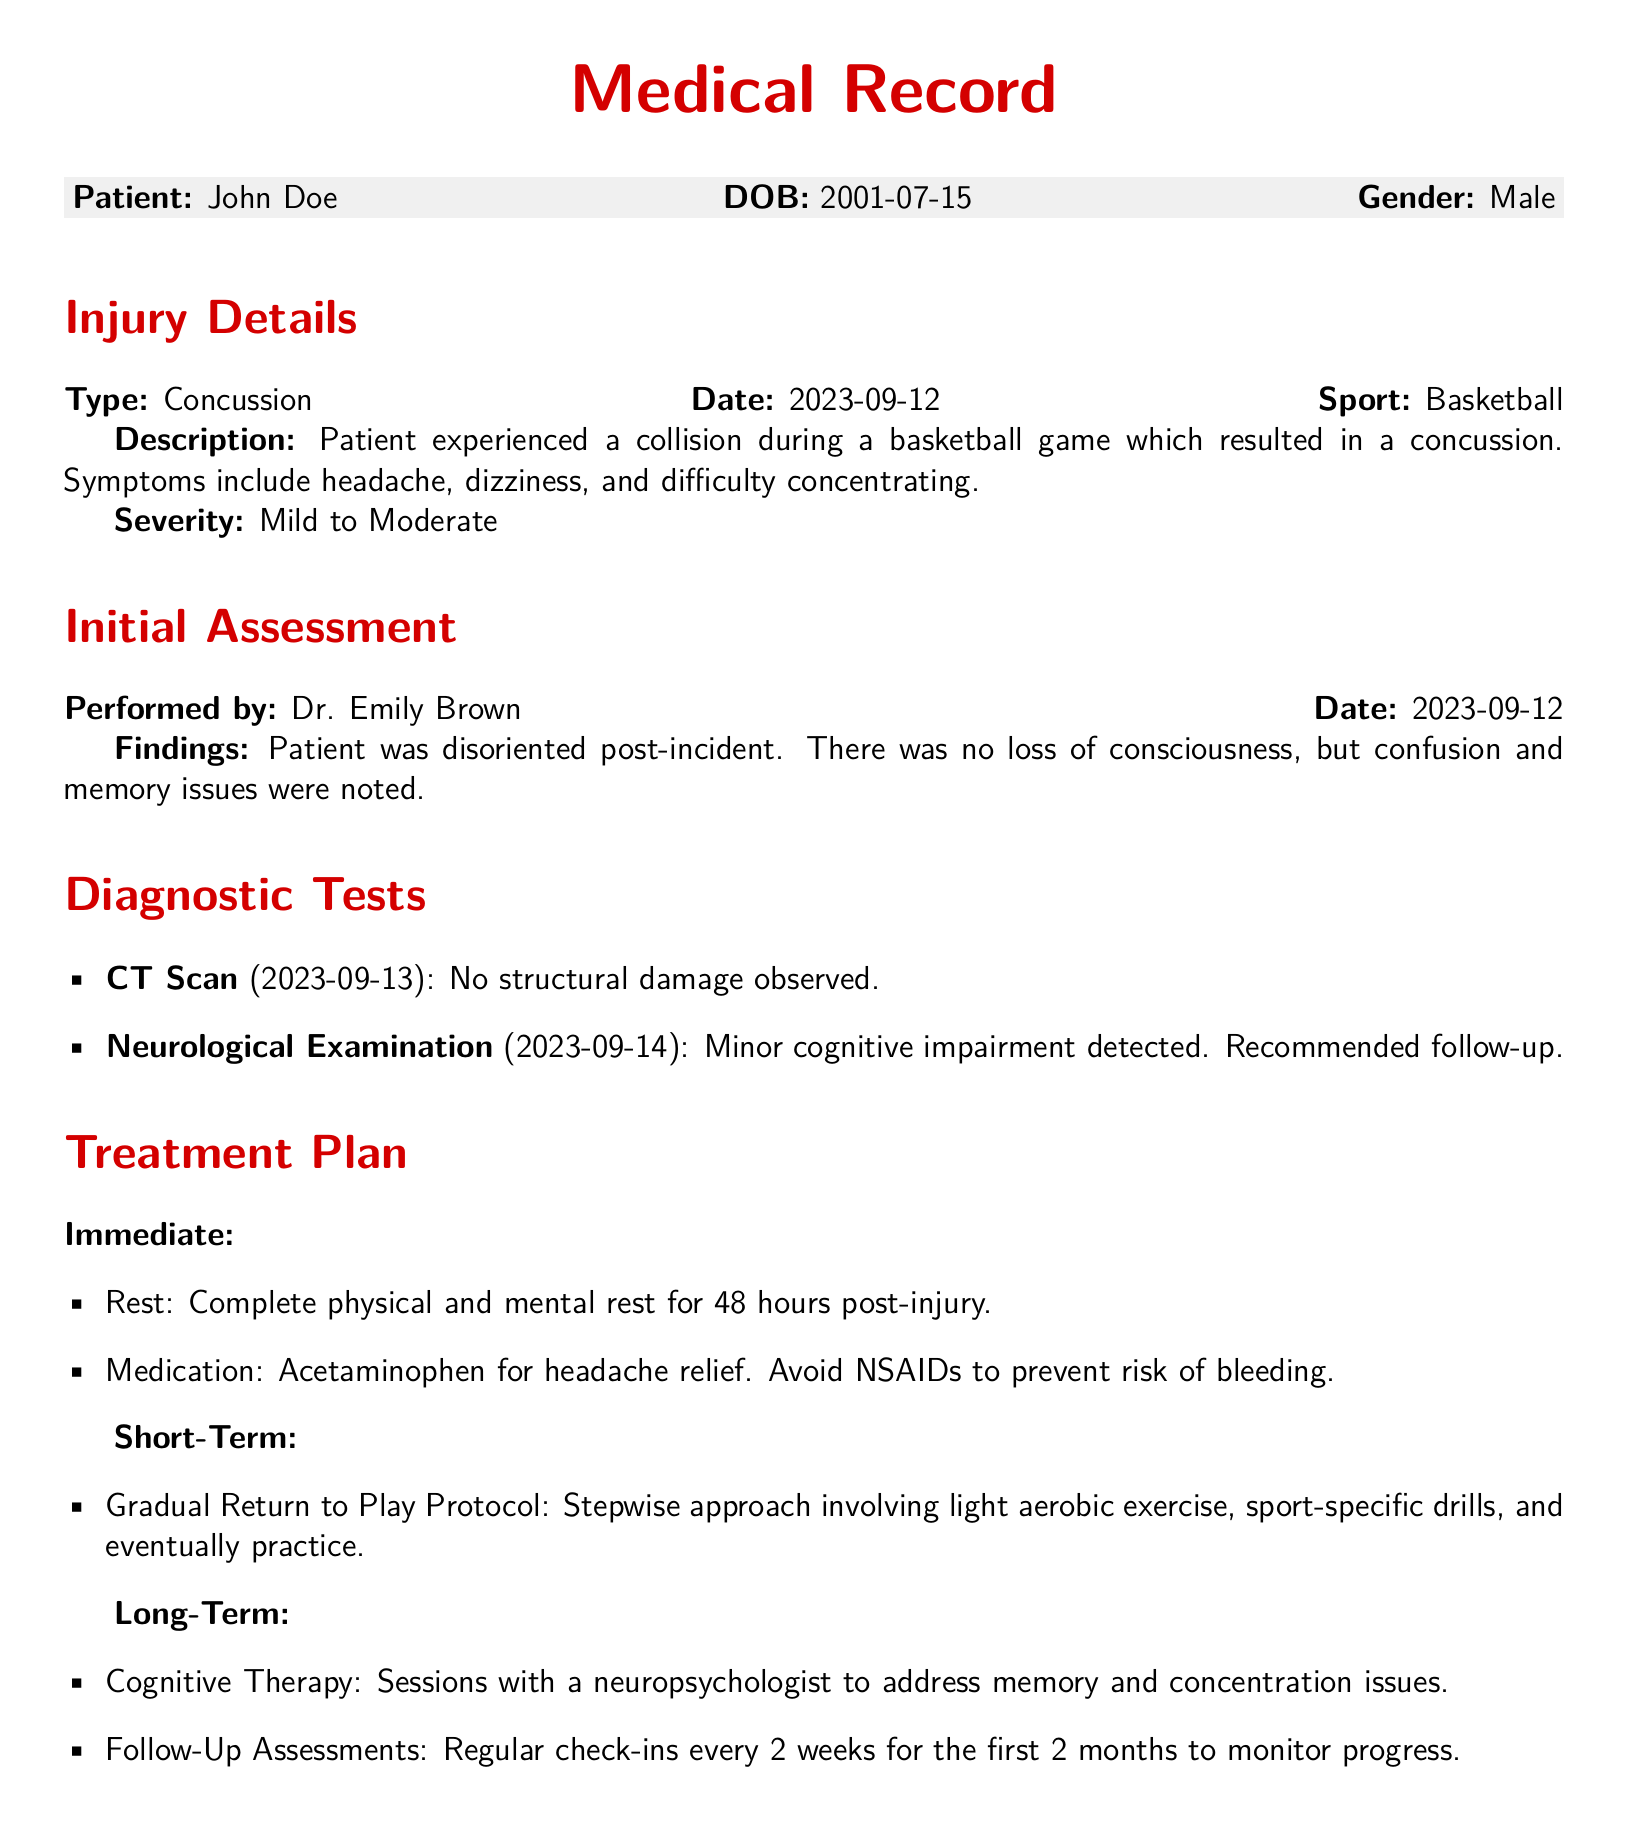What type of injury did the patient experience? The type of injury is specified in the "Injury Details" section of the document, which states "Concussion."
Answer: Concussion What sport was the patient playing when the injury occurred? The sport is indicated in the "Injury Details" section, which notes "Basketball."
Answer: Basketball Who performed the initial assessment? The name of the medical professional who performed the assessment is mentioned in the "Initial Assessment" section, stating "Dr. Emily Brown."
Answer: Dr. Emily Brown What date was the concussion diagnosed? The date of the injury is mentioned in the "Injury Details" section, which indicates "2023-09-12."
Answer: 2023-09-12 What is the recommended follow-up frequency after the injury? The follow-up assessments are detailed in the "Long-Term" treatment plan, indicating a frequency of "every 2 weeks for the first 2 months."
Answer: every 2 weeks for the first 2 months What immediate medication was prescribed for headache relief? The treatment plan states to use "Acetaminophen" for headache relief, as mentioned in the "Immediate" treatment section.
Answer: Acetaminophen What kind of exercises are included in the rehabilitation plan? The "Rehabilitation Exercises" section lists specific exercises, beginning with "Light Aerobic Exercise."
Answer: Light Aerobic Exercise What symptom was noted during the neurological examination? The neurological examination notes "Minor cognitive impairment," indicating the presence of this symptom.
Answer: Minor cognitive impairment What advice is noted regarding activities post-injury? The "Notes" section recommends that the patient should "avoid any high-risk activities that could lead to re-injury."
Answer: avoid any high-risk activities that could lead to re-injury 